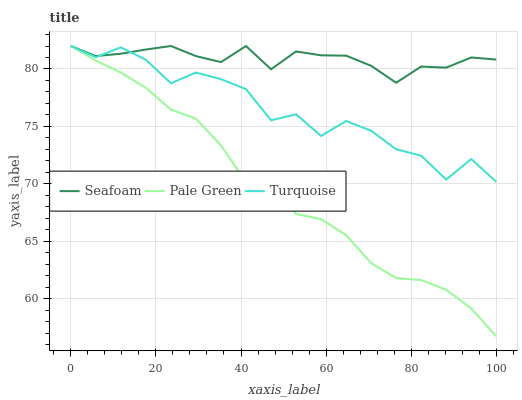Does Pale Green have the minimum area under the curve?
Answer yes or no. Yes. Does Seafoam have the maximum area under the curve?
Answer yes or no. Yes. Does Seafoam have the minimum area under the curve?
Answer yes or no. No. Does Pale Green have the maximum area under the curve?
Answer yes or no. No. Is Pale Green the smoothest?
Answer yes or no. Yes. Is Turquoise the roughest?
Answer yes or no. Yes. Is Seafoam the smoothest?
Answer yes or no. No. Is Seafoam the roughest?
Answer yes or no. No. Does Seafoam have the lowest value?
Answer yes or no. No. Does Seafoam have the highest value?
Answer yes or no. Yes. Does Seafoam intersect Pale Green?
Answer yes or no. Yes. Is Seafoam less than Pale Green?
Answer yes or no. No. Is Seafoam greater than Pale Green?
Answer yes or no. No. 